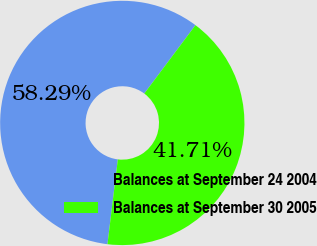Convert chart to OTSL. <chart><loc_0><loc_0><loc_500><loc_500><pie_chart><fcel>Balances at September 24 2004<fcel>Balances at September 30 2005<nl><fcel>58.29%<fcel>41.71%<nl></chart> 